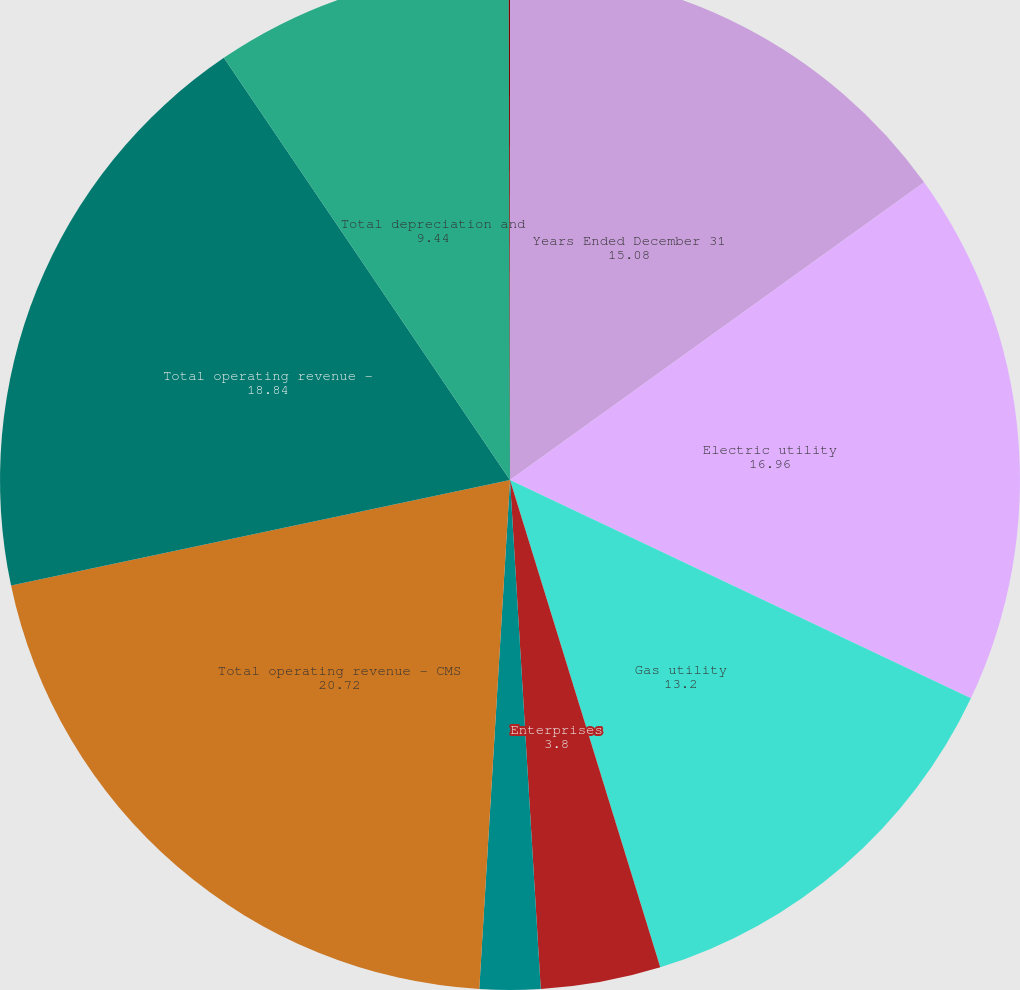Convert chart to OTSL. <chart><loc_0><loc_0><loc_500><loc_500><pie_chart><fcel>Years Ended December 31<fcel>Electric utility<fcel>Gas utility<fcel>Enterprises<fcel>Other reconciling items<fcel>Total operating revenue - CMS<fcel>Total operating revenue -<fcel>Total depreciation and<fcel>Total income from equity<nl><fcel>15.08%<fcel>16.96%<fcel>13.2%<fcel>3.8%<fcel>1.92%<fcel>20.72%<fcel>18.84%<fcel>9.44%<fcel>0.04%<nl></chart> 